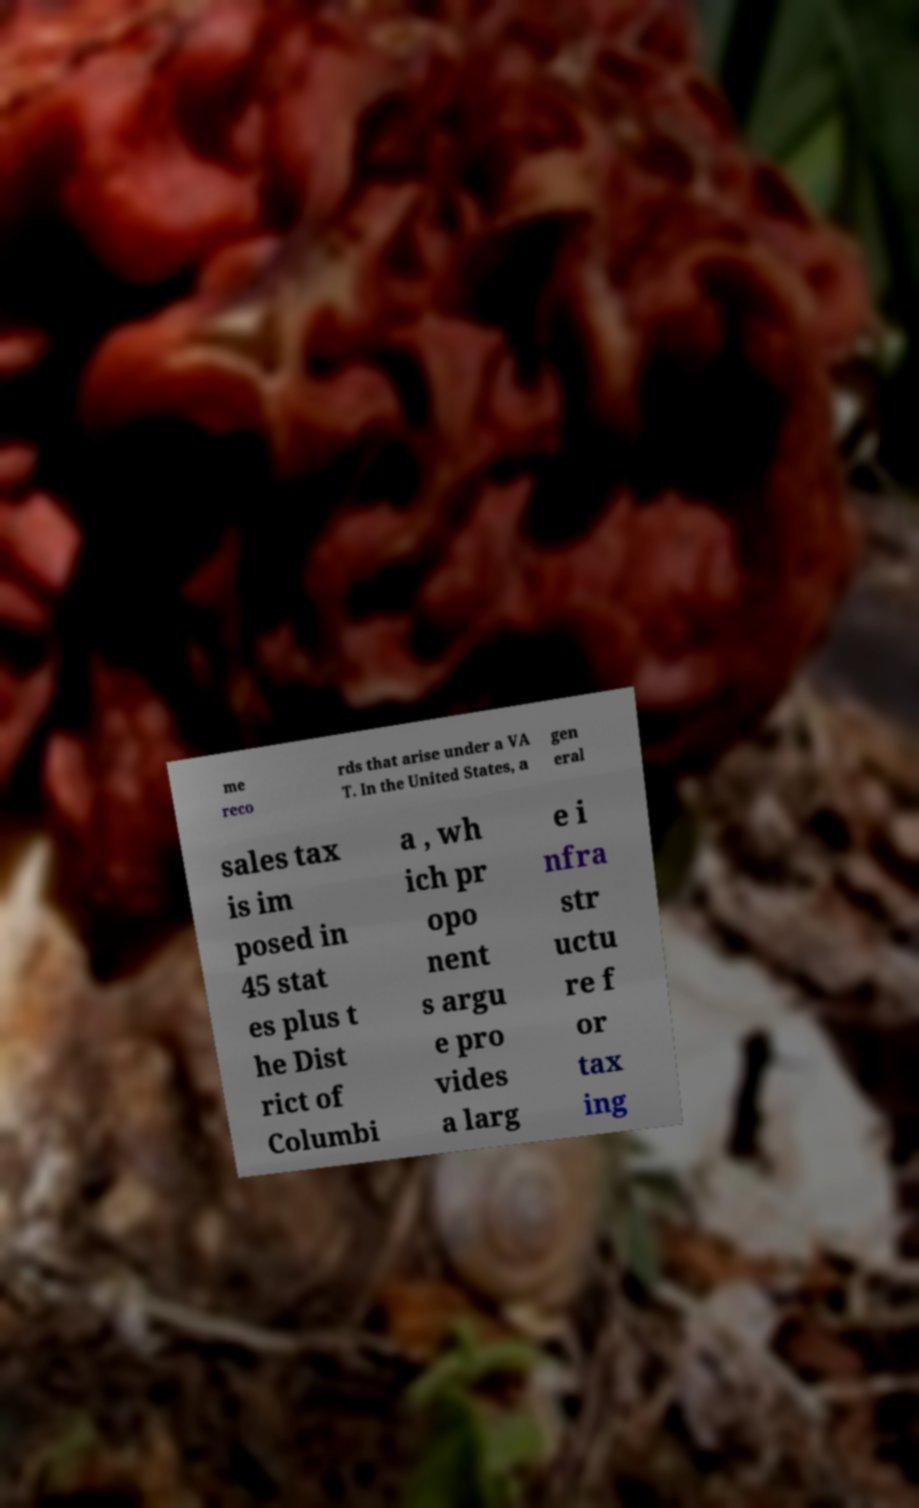Could you assist in decoding the text presented in this image and type it out clearly? me reco rds that arise under a VA T. In the United States, a gen eral sales tax is im posed in 45 stat es plus t he Dist rict of Columbi a , wh ich pr opo nent s argu e pro vides a larg e i nfra str uctu re f or tax ing 